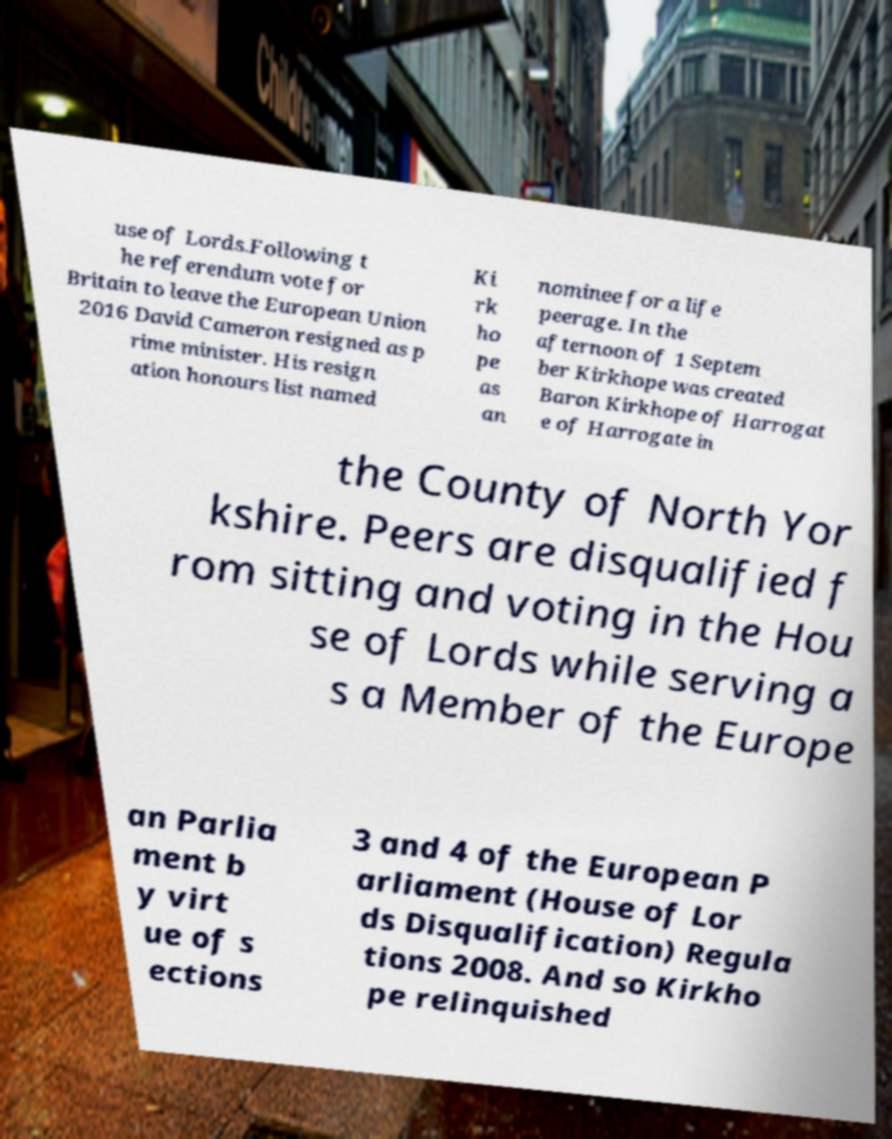Please read and relay the text visible in this image. What does it say? use of Lords.Following t he referendum vote for Britain to leave the European Union 2016 David Cameron resigned as p rime minister. His resign ation honours list named Ki rk ho pe as an nominee for a life peerage. In the afternoon of 1 Septem ber Kirkhope was created Baron Kirkhope of Harrogat e of Harrogate in the County of North Yor kshire. Peers are disqualified f rom sitting and voting in the Hou se of Lords while serving a s a Member of the Europe an Parlia ment b y virt ue of s ections 3 and 4 of the European P arliament (House of Lor ds Disqualification) Regula tions 2008. And so Kirkho pe relinquished 